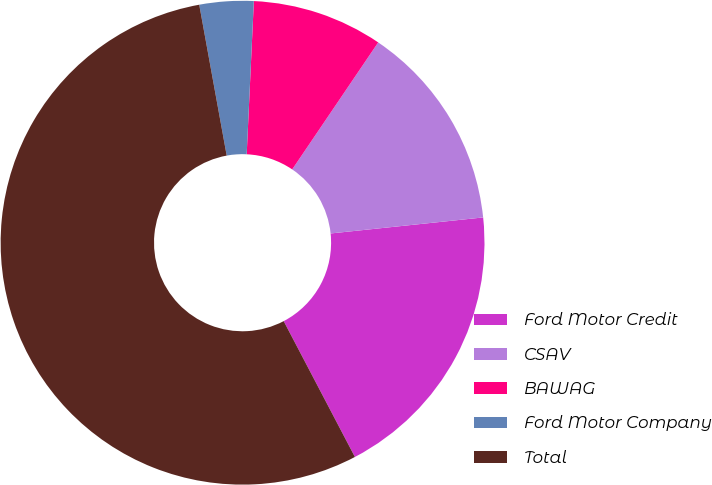Convert chart to OTSL. <chart><loc_0><loc_0><loc_500><loc_500><pie_chart><fcel>Ford Motor Credit<fcel>CSAV<fcel>BAWAG<fcel>Ford Motor Company<fcel>Total<nl><fcel>18.98%<fcel>13.86%<fcel>8.73%<fcel>3.61%<fcel>54.82%<nl></chart> 